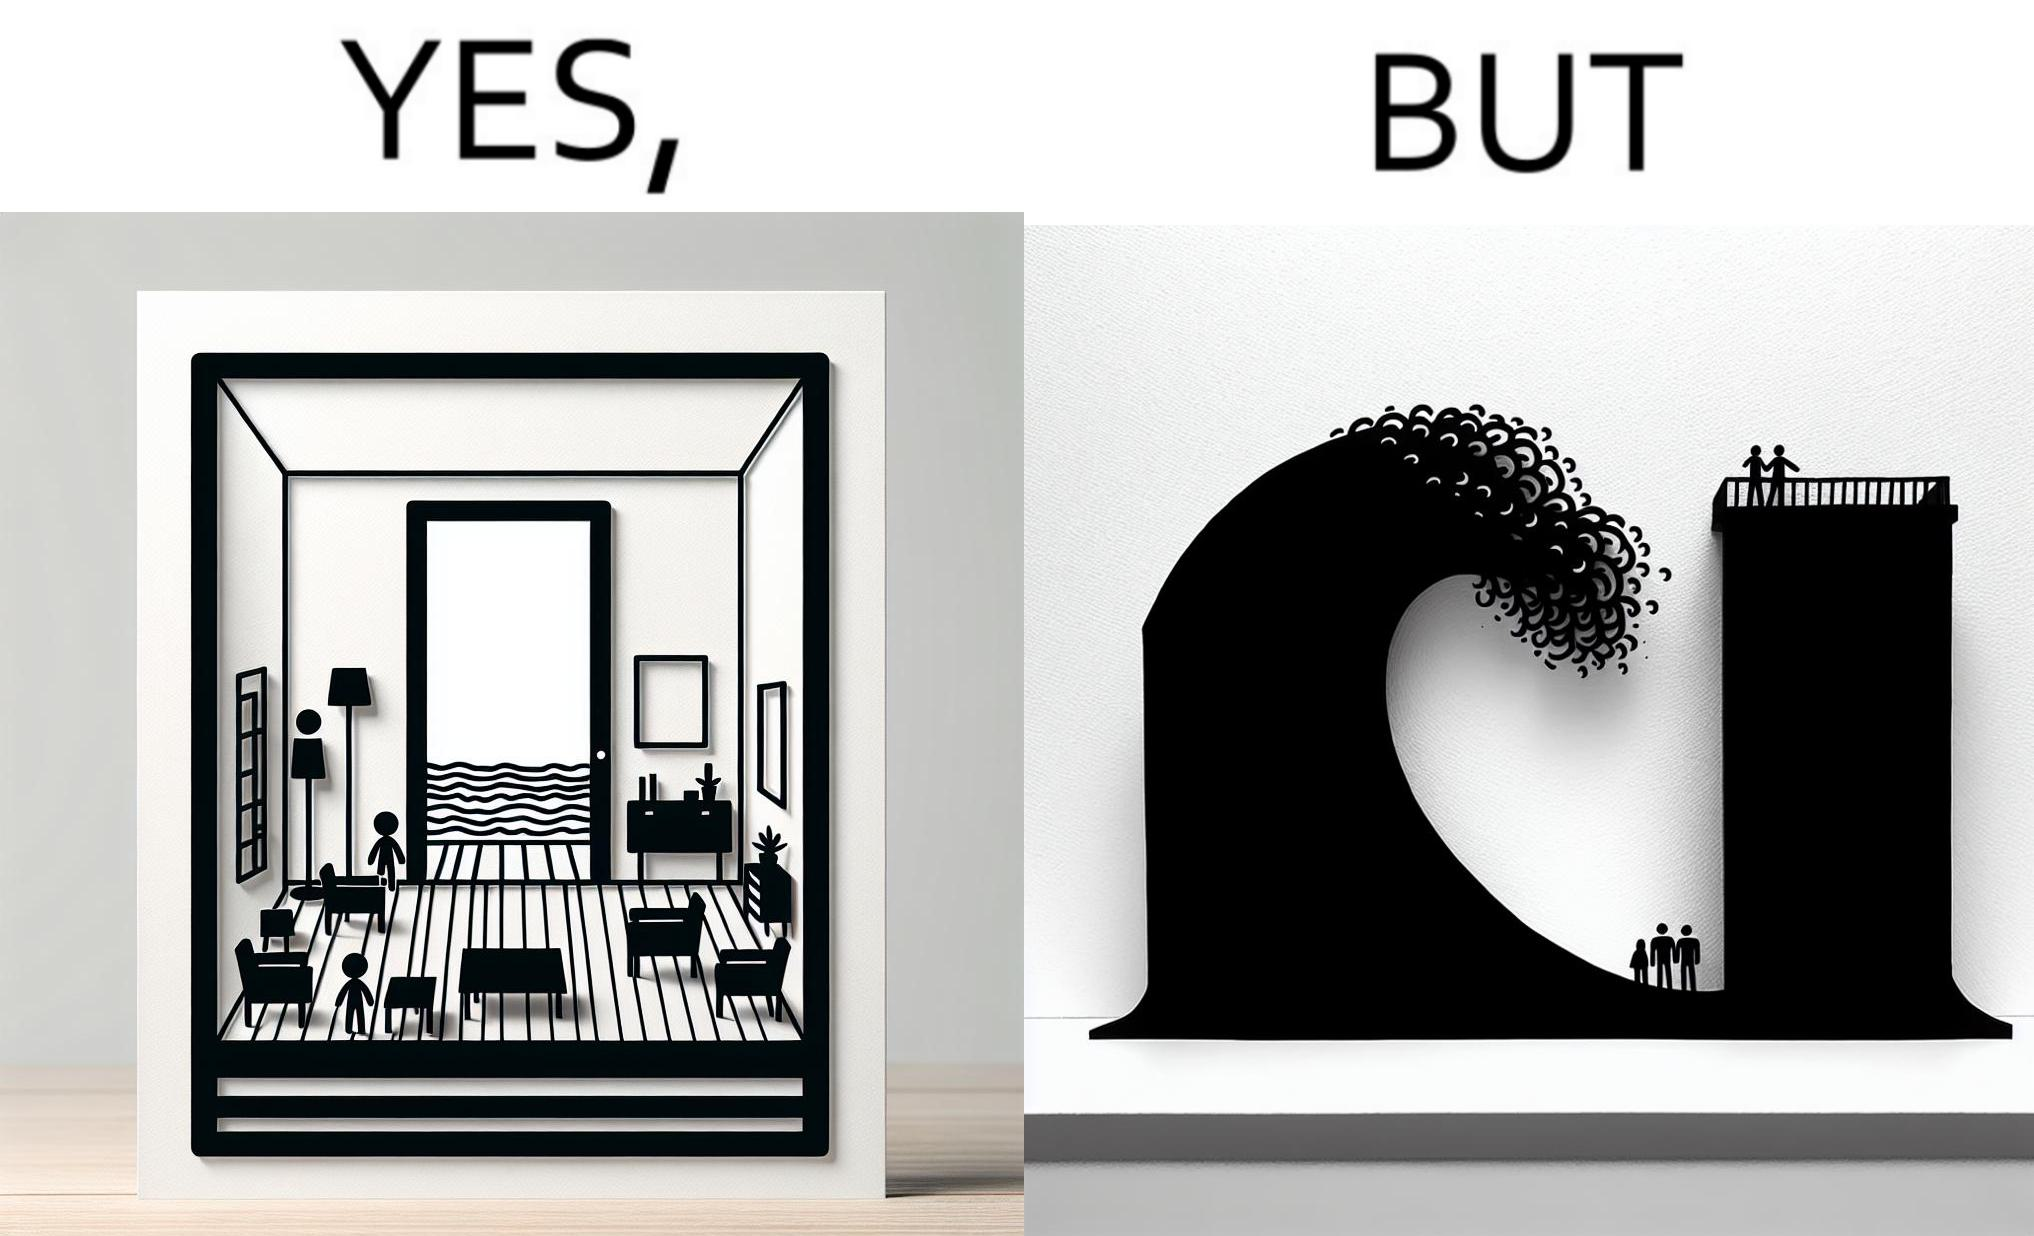Describe what you see in this image. The same sea which gives us a relaxation on a normal day can pose a danger to us sometimes like during a tsunami 